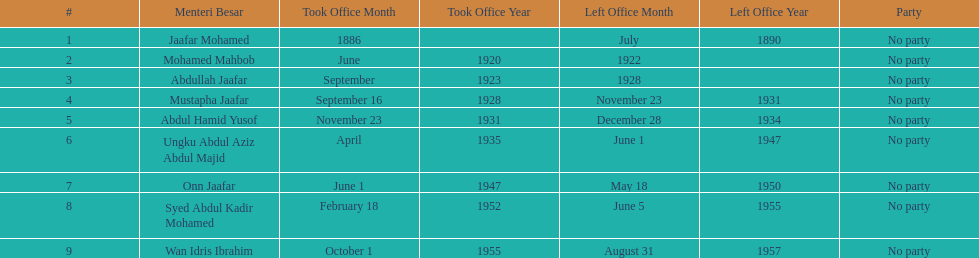When did jaafar mohamed take office? 1886. When did mohamed mahbob take office? June 1920. Who was in office no more than 4 years? Mohamed Mahbob. 